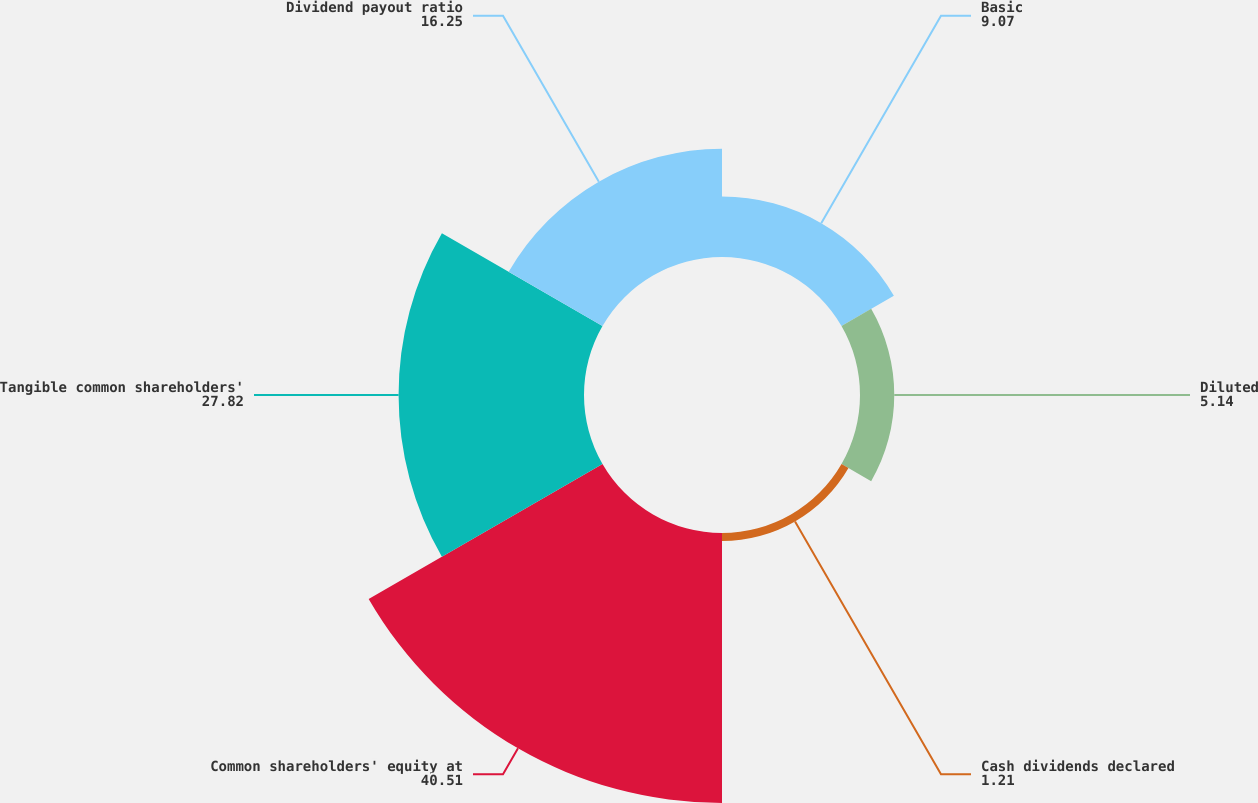<chart> <loc_0><loc_0><loc_500><loc_500><pie_chart><fcel>Basic<fcel>Diluted<fcel>Cash dividends declared<fcel>Common shareholders' equity at<fcel>Tangible common shareholders'<fcel>Dividend payout ratio<nl><fcel>9.07%<fcel>5.14%<fcel>1.21%<fcel>40.51%<fcel>27.82%<fcel>16.25%<nl></chart> 